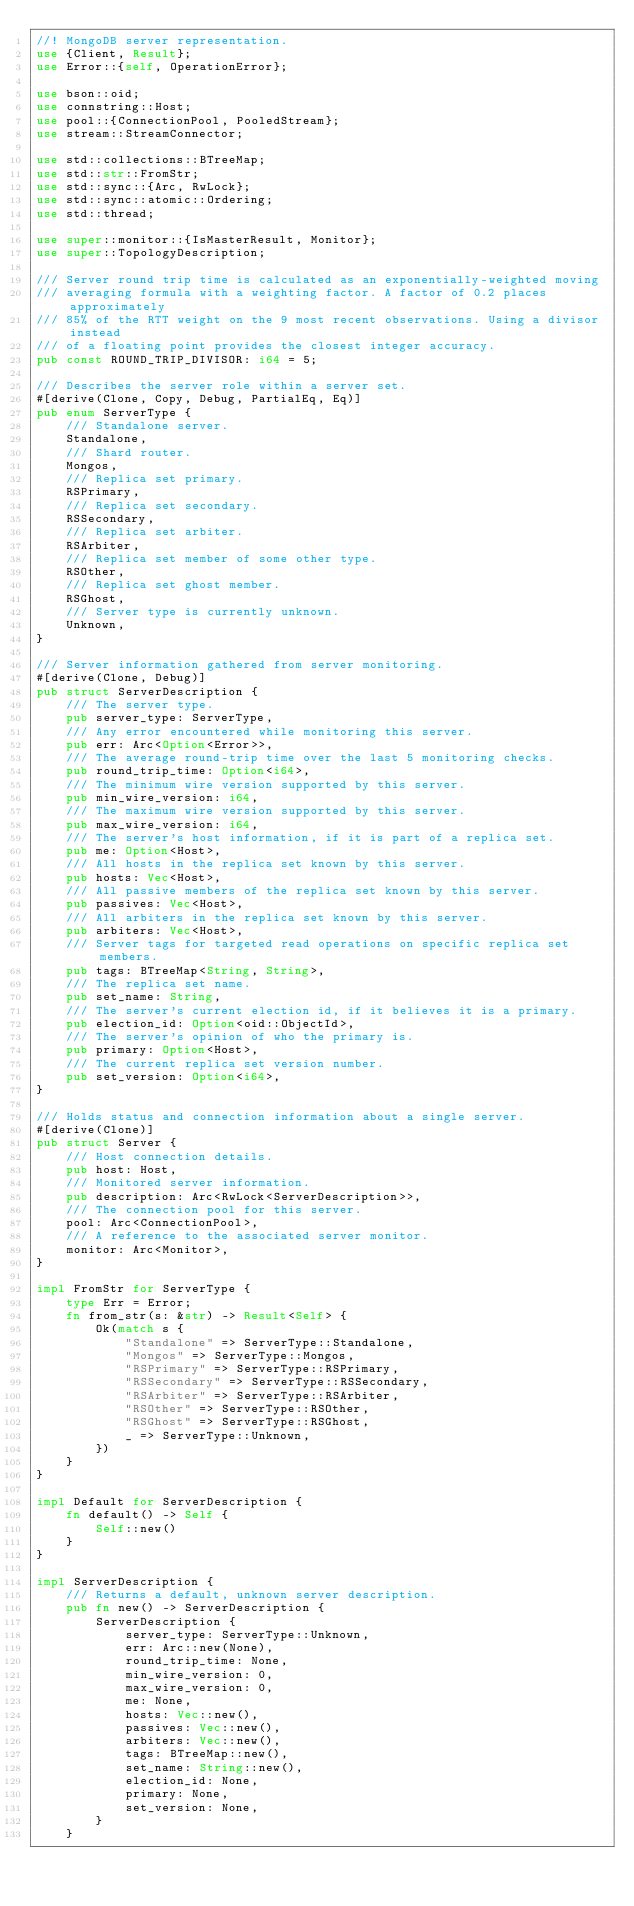Convert code to text. <code><loc_0><loc_0><loc_500><loc_500><_Rust_>//! MongoDB server representation.
use {Client, Result};
use Error::{self, OperationError};

use bson::oid;
use connstring::Host;
use pool::{ConnectionPool, PooledStream};
use stream::StreamConnector;

use std::collections::BTreeMap;
use std::str::FromStr;
use std::sync::{Arc, RwLock};
use std::sync::atomic::Ordering;
use std::thread;

use super::monitor::{IsMasterResult, Monitor};
use super::TopologyDescription;

/// Server round trip time is calculated as an exponentially-weighted moving
/// averaging formula with a weighting factor. A factor of 0.2 places approximately
/// 85% of the RTT weight on the 9 most recent observations. Using a divisor instead
/// of a floating point provides the closest integer accuracy.
pub const ROUND_TRIP_DIVISOR: i64 = 5;

/// Describes the server role within a server set.
#[derive(Clone, Copy, Debug, PartialEq, Eq)]
pub enum ServerType {
    /// Standalone server.
    Standalone,
    /// Shard router.
    Mongos,
    /// Replica set primary.
    RSPrimary,
    /// Replica set secondary.
    RSSecondary,
    /// Replica set arbiter.
    RSArbiter,
    /// Replica set member of some other type.
    RSOther,
    /// Replica set ghost member.
    RSGhost,
    /// Server type is currently unknown.
    Unknown,
}

/// Server information gathered from server monitoring.
#[derive(Clone, Debug)]
pub struct ServerDescription {
    /// The server type.
    pub server_type: ServerType,
    /// Any error encountered while monitoring this server.
    pub err: Arc<Option<Error>>,
    /// The average round-trip time over the last 5 monitoring checks.
    pub round_trip_time: Option<i64>,
    /// The minimum wire version supported by this server.
    pub min_wire_version: i64,
    /// The maximum wire version supported by this server.
    pub max_wire_version: i64,
    /// The server's host information, if it is part of a replica set.
    pub me: Option<Host>,
    /// All hosts in the replica set known by this server.
    pub hosts: Vec<Host>,
    /// All passive members of the replica set known by this server.
    pub passives: Vec<Host>,
    /// All arbiters in the replica set known by this server.
    pub arbiters: Vec<Host>,
    /// Server tags for targeted read operations on specific replica set members.
    pub tags: BTreeMap<String, String>,
    /// The replica set name.
    pub set_name: String,
    /// The server's current election id, if it believes it is a primary.
    pub election_id: Option<oid::ObjectId>,
    /// The server's opinion of who the primary is.
    pub primary: Option<Host>,
    /// The current replica set version number.
    pub set_version: Option<i64>,
}

/// Holds status and connection information about a single server.
#[derive(Clone)]
pub struct Server {
    /// Host connection details.
    pub host: Host,
    /// Monitored server information.
    pub description: Arc<RwLock<ServerDescription>>,
    /// The connection pool for this server.
    pool: Arc<ConnectionPool>,
    /// A reference to the associated server monitor.
    monitor: Arc<Monitor>,
}

impl FromStr for ServerType {
    type Err = Error;
    fn from_str(s: &str) -> Result<Self> {
        Ok(match s {
            "Standalone" => ServerType::Standalone,
            "Mongos" => ServerType::Mongos,
            "RSPrimary" => ServerType::RSPrimary,
            "RSSecondary" => ServerType::RSSecondary,
            "RSArbiter" => ServerType::RSArbiter,
            "RSOther" => ServerType::RSOther,
            "RSGhost" => ServerType::RSGhost,
            _ => ServerType::Unknown,
        })
    }
}

impl Default for ServerDescription {
    fn default() -> Self {
        Self::new()
    }
}

impl ServerDescription {
    /// Returns a default, unknown server description.
    pub fn new() -> ServerDescription {
        ServerDescription {
            server_type: ServerType::Unknown,
            err: Arc::new(None),
            round_trip_time: None,
            min_wire_version: 0,
            max_wire_version: 0,
            me: None,
            hosts: Vec::new(),
            passives: Vec::new(),
            arbiters: Vec::new(),
            tags: BTreeMap::new(),
            set_name: String::new(),
            election_id: None,
            primary: None,
            set_version: None,
        }
    }
</code> 